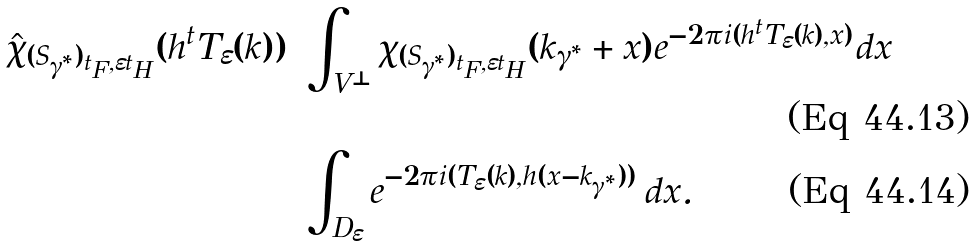<formula> <loc_0><loc_0><loc_500><loc_500>\hat { \chi } _ { ( S _ { \gamma ^ { * } } ) _ { t _ { F } , \varepsilon t _ { H } } } ( h ^ { t } T _ { \varepsilon } ( k ) ) = & \int _ { V ^ { \bot } } \chi _ { ( S _ { \gamma ^ { * } } ) _ { t _ { F } , \varepsilon t _ { H } } } ( k _ { \gamma ^ { * } } + x ) e ^ { - 2 \pi i ( h ^ { t } T _ { \varepsilon } ( k ) , x ) } d x \\ = & \int _ { D _ { \varepsilon } } e ^ { - 2 \pi i ( T _ { \varepsilon } ( k ) , h ( x - k _ { \gamma ^ { * } } ) ) } \, d x .</formula> 